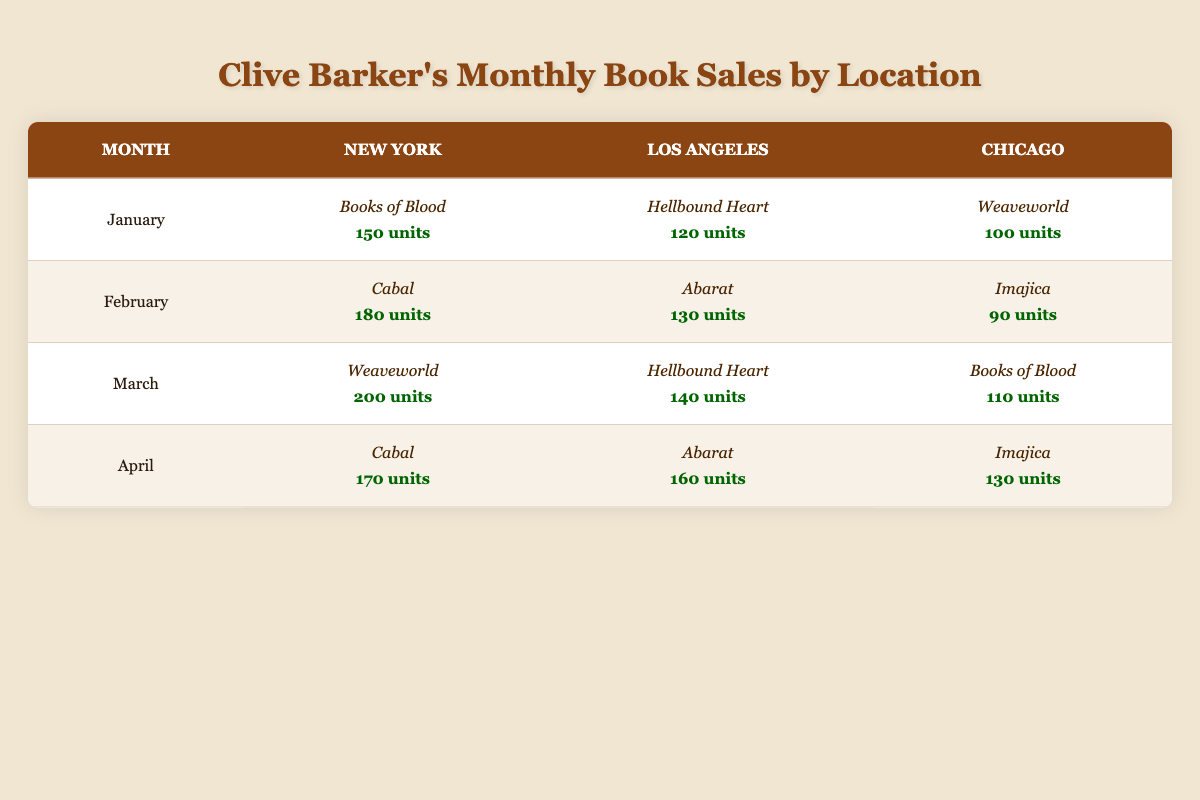What book sold the most units in New York in March? In March, "Weaveworld" sold 200 units in New York, which is the highest single entry for that month compared to other titles in the same location.
Answer: Weaveworld Which location had the highest sales for "Abarat"? In April, "Abarat" sold 160 units in Los Angeles, which is the only entry for this title across all months. Thus, this is the highest sales value for "Abarat".
Answer: Los Angeles What is the total number of units sold for "Cabal" across all months? "Cabal" sold 180 units in February and 170 units in April, making the total units sold 180 + 170 = 350.
Answer: 350 Did "Books of Blood" sell more units in January than in March? In January, "Books of Blood" sold 150 units, while in March, it sold 110 units. Since 150 units is greater than 110 units, the answer is yes.
Answer: Yes Which book had the lowest sales in Chicago over the four months? The sales in Chicago for each month are: 100 units for "Weaveworld" in January, 90 units for "Imajica" in February, 110 units for "Books of Blood" in March, and 130 units for "Imajica" in April. The lowest is 90 units for "Imajica" in February.
Answer: Imajica 